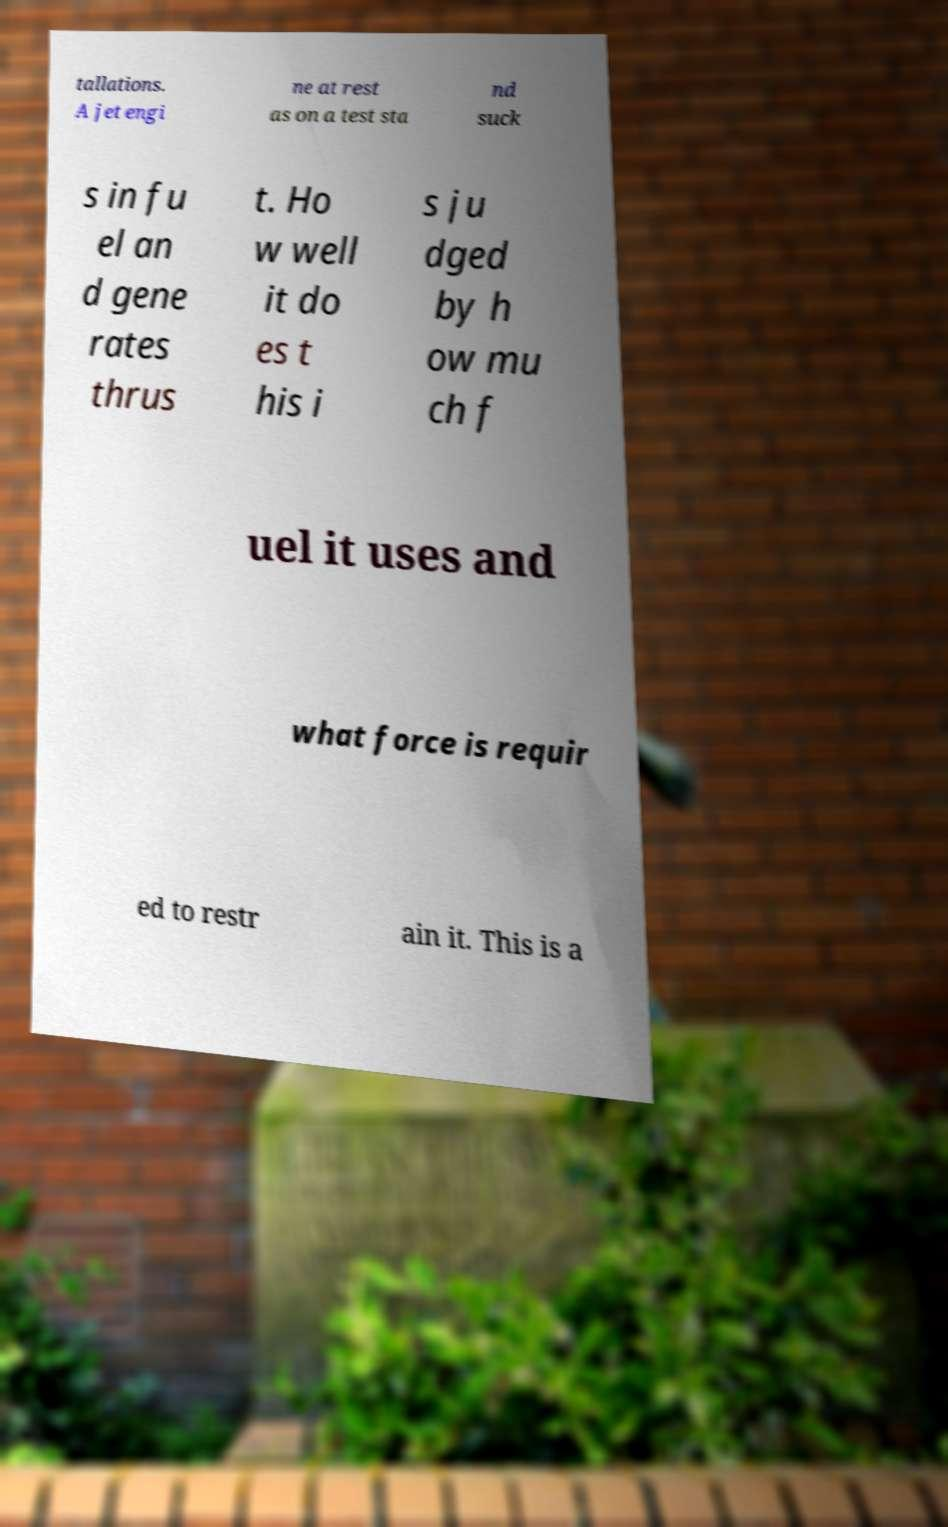There's text embedded in this image that I need extracted. Can you transcribe it verbatim? tallations. A jet engi ne at rest as on a test sta nd suck s in fu el an d gene rates thrus t. Ho w well it do es t his i s ju dged by h ow mu ch f uel it uses and what force is requir ed to restr ain it. This is a 